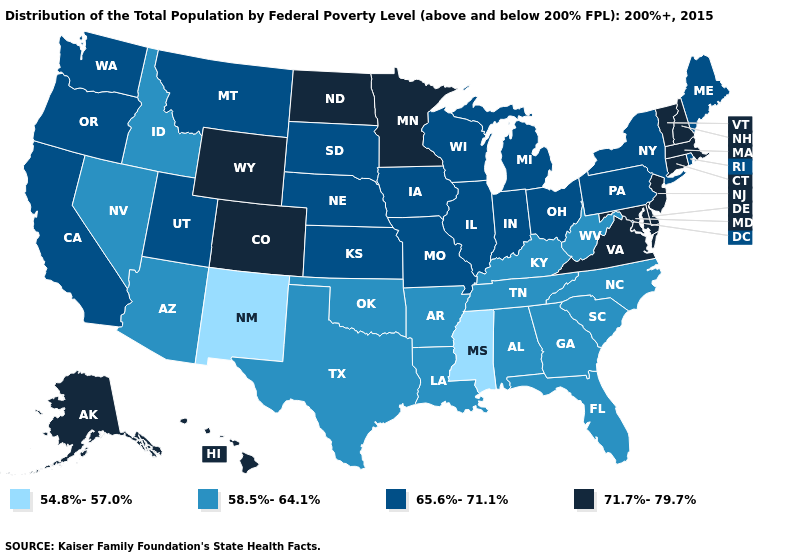Which states hav the highest value in the West?
Concise answer only. Alaska, Colorado, Hawaii, Wyoming. What is the lowest value in states that border North Dakota?
Answer briefly. 65.6%-71.1%. What is the value of Wisconsin?
Give a very brief answer. 65.6%-71.1%. What is the value of California?
Be succinct. 65.6%-71.1%. Is the legend a continuous bar?
Write a very short answer. No. Which states have the lowest value in the MidWest?
Keep it brief. Illinois, Indiana, Iowa, Kansas, Michigan, Missouri, Nebraska, Ohio, South Dakota, Wisconsin. What is the value of New York?
Quick response, please. 65.6%-71.1%. What is the value of Rhode Island?
Give a very brief answer. 65.6%-71.1%. Name the states that have a value in the range 54.8%-57.0%?
Be succinct. Mississippi, New Mexico. Among the states that border Tennessee , does Mississippi have the lowest value?
Be succinct. Yes. Which states have the lowest value in the USA?
Give a very brief answer. Mississippi, New Mexico. Does Pennsylvania have the lowest value in the Northeast?
Keep it brief. Yes. What is the lowest value in states that border New York?
Give a very brief answer. 65.6%-71.1%. Does Wyoming have the highest value in the West?
Give a very brief answer. Yes. What is the value of Colorado?
Keep it brief. 71.7%-79.7%. 